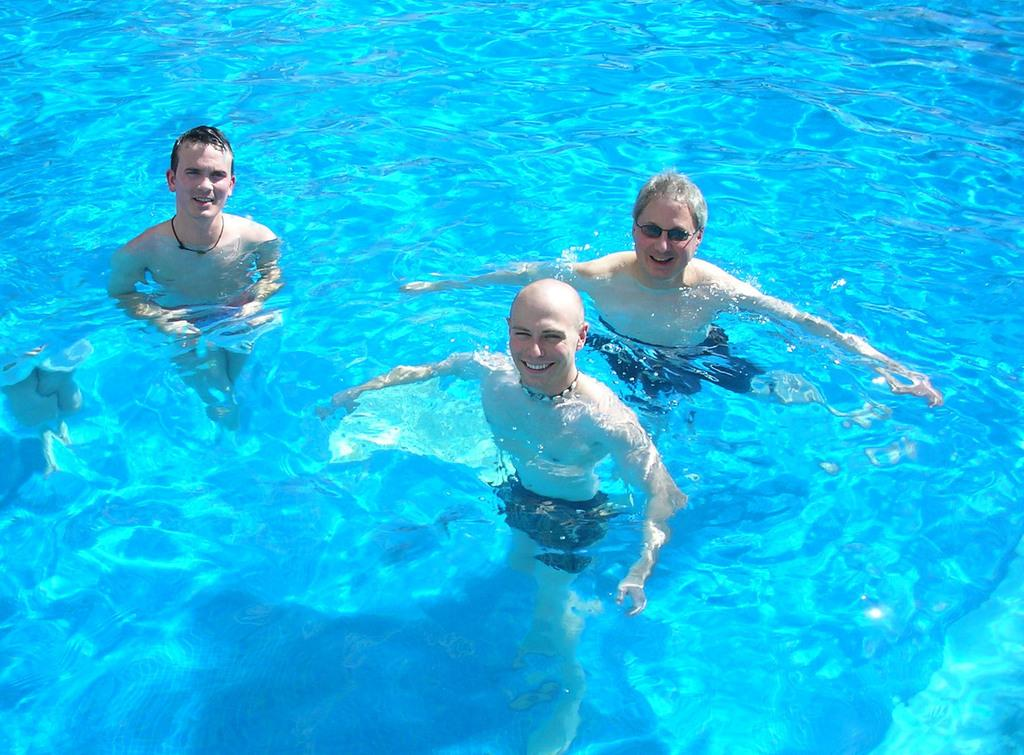What are the people in the image doing? The people in the image are in the water. Can you describe the person on the right side of the image? There is a person wearing goggles on the right side of the image. What type of feather can be seen floating in the water in the image? There is no feather present in the water in the image. What kind of punishment is being administered to the people in the water in the image? There is no punishment being administered to the people in the water in the image. 